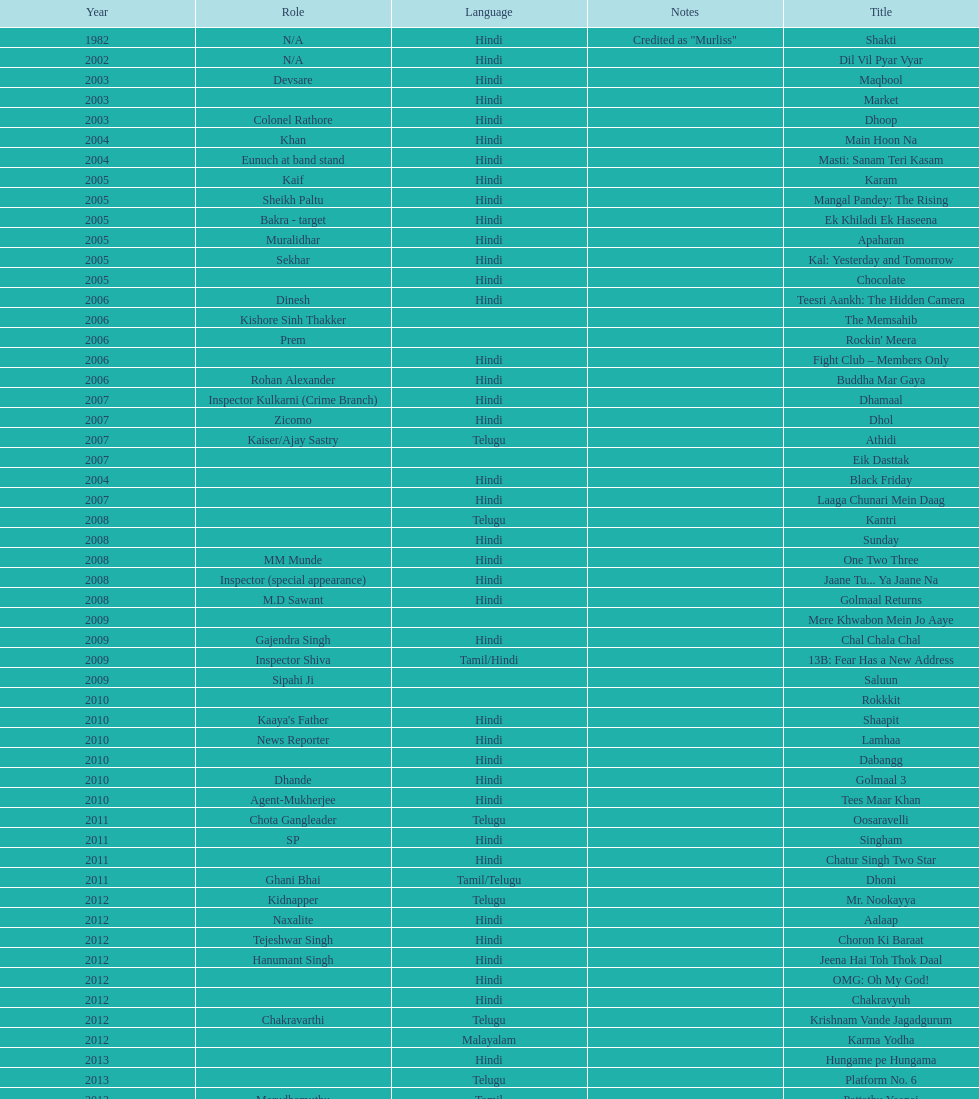What is the first language after hindi Telugu. 